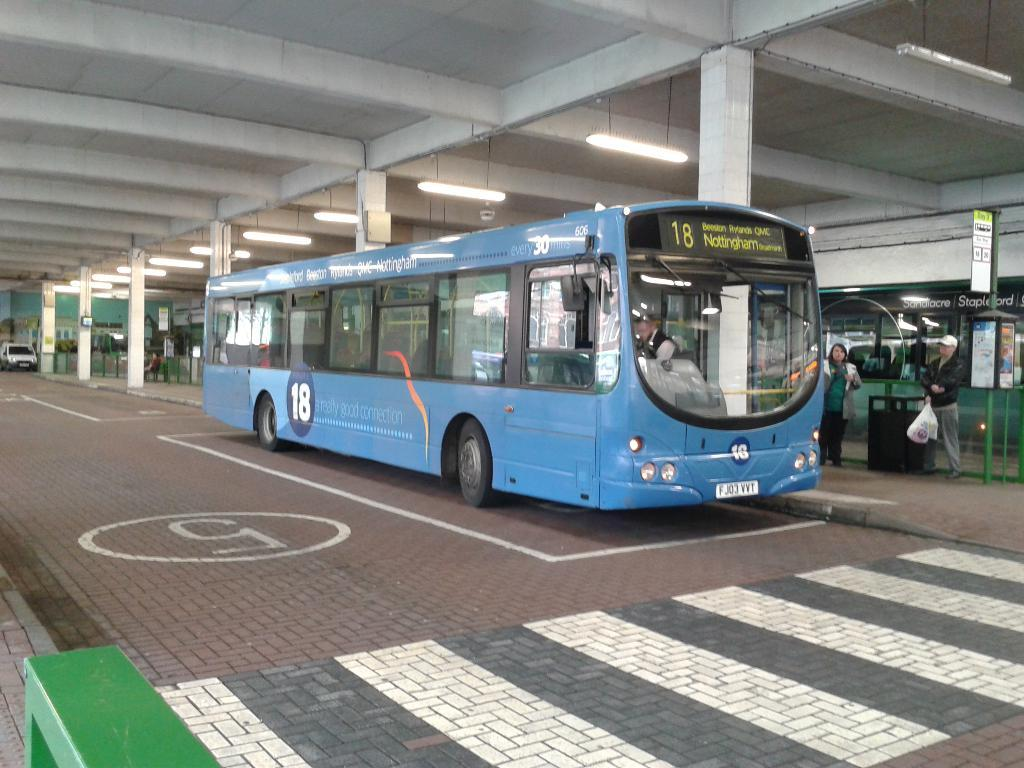<image>
Describe the image concisely. A blue bus that is destined for Nottingham is waiting at a bus stop. 